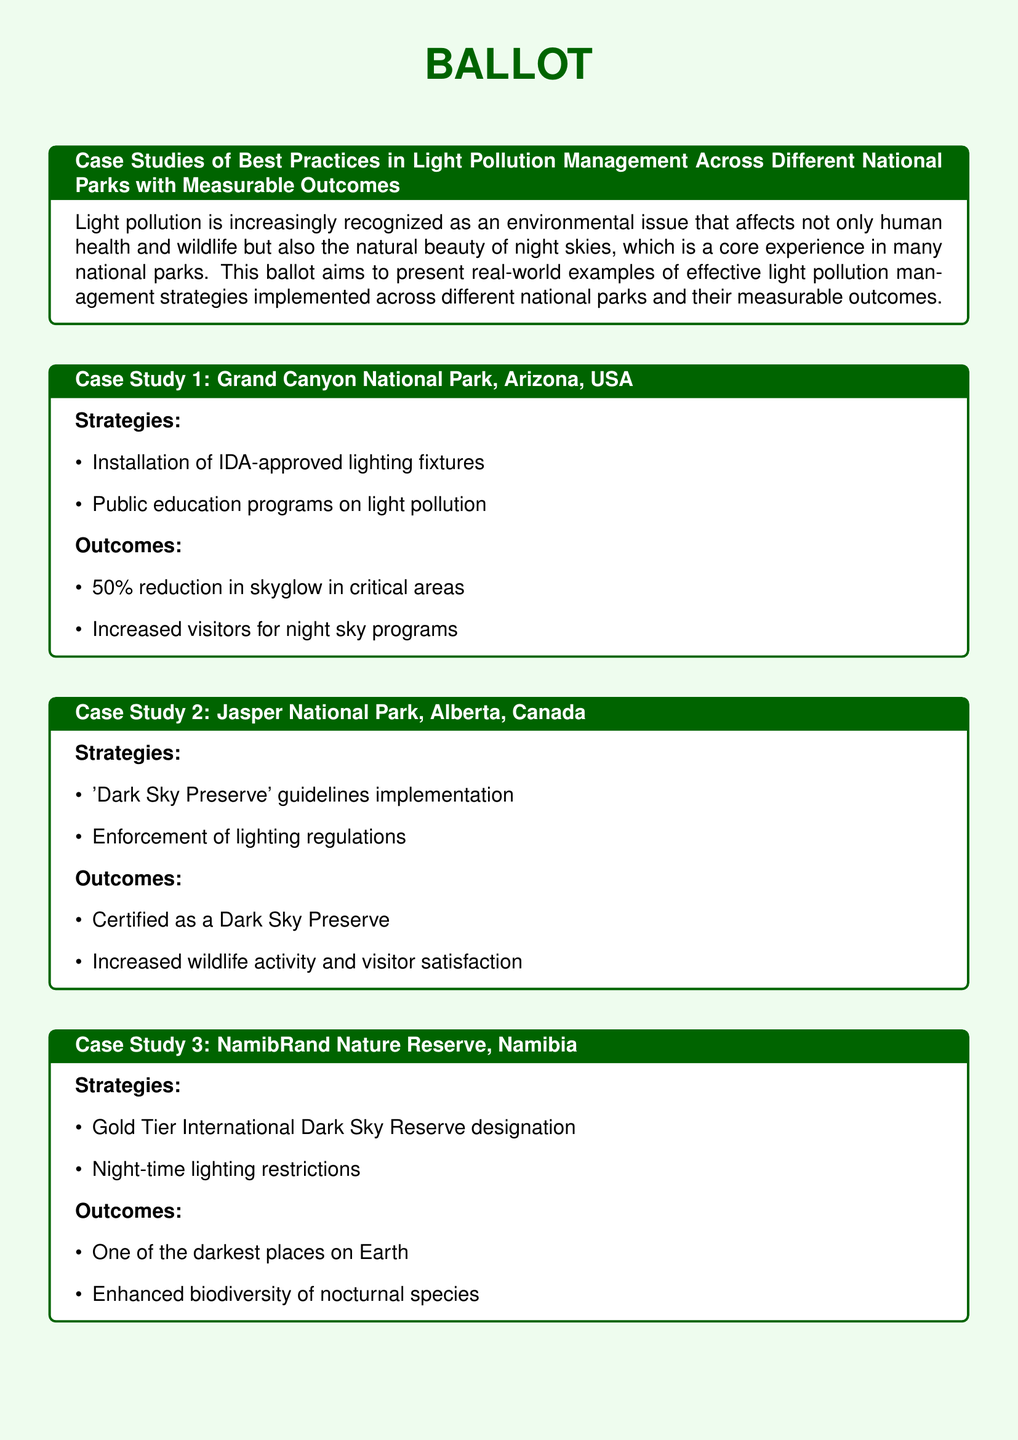what is the first case study mentioned? The first case study discussed is Grand Canyon National Park, Arizona, USA.
Answer: Grand Canyon National Park, Arizona, USA what percentage reduction in skyglow did Grand Canyon National Park achieve? The document states that Grand Canyon National Park achieved a 50% reduction in skyglow in critical areas.
Answer: 50% which national park is certified as a Dark Sky Preserve? According to the document, Jasper National Park is certified as a Dark Sky Preserve.
Answer: Jasper National Park what designation has the NamibRand Nature Reserve achieved? The NamibRand Nature Reserve has achieved Gold Tier International Dark Sky Reserve designation.
Answer: Gold Tier International Dark Sky Reserve what is one outcome of the collaboration with local governments in New Zealand's Aoraki Mackenzie? The outcome of the collaboration resulted in a significant increase in astro-tourism.
Answer: significant increase in astro-tourism which case study mentions an increase in wildlife activity? The case study that mentions an increase in wildlife activity is Jasper National Park, Alberta, Canada.
Answer: Jasper National Park, Alberta, Canada how does the document describe the light pollution strategies in the Grand Canyon? The light pollution strategies in the Grand Canyon include installation of IDA-approved lighting fixtures and public education programs.
Answer: installation of IDA-approved lighting fixtures and public education programs what type of promotional campaigns were conducted in Aoraki Mackenzie? The document mentions that astro-tourism promotional campaigns were conducted in Aoraki Mackenzie.
Answer: astro-tourism promotional campaigns 